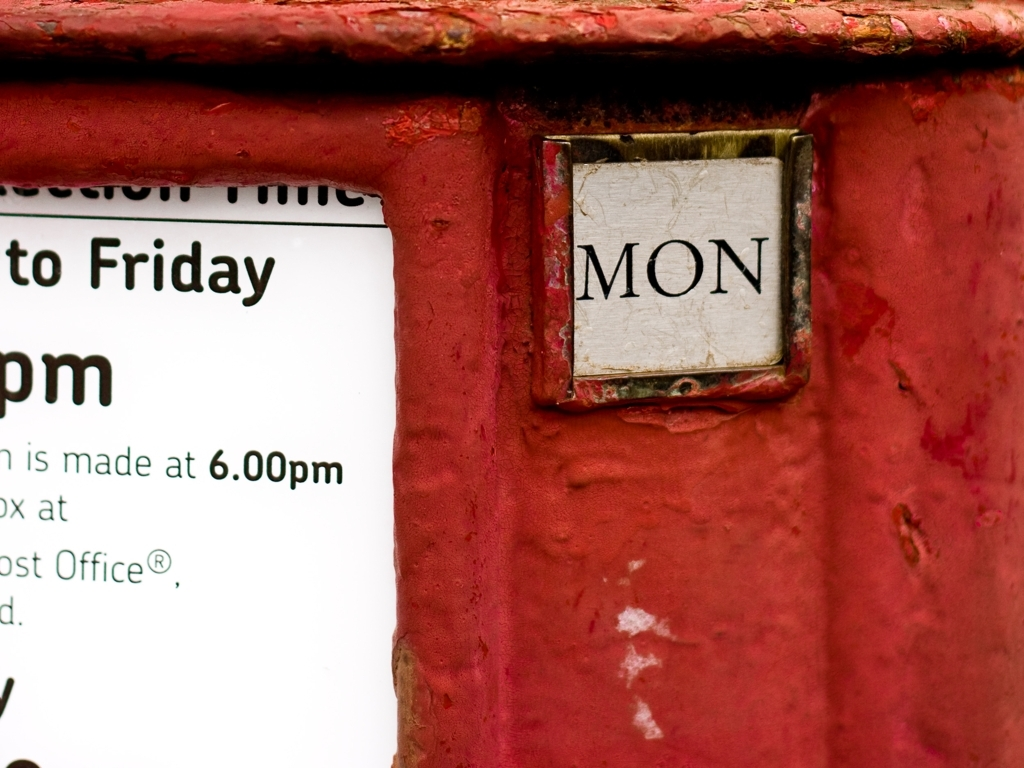Can you tell me anything about the history or significance of such signs on postal boxes? Signs like this are embedded in the rich history of postal services. They traditionally indicate the collection times and often include the day of the week to guide the public. Such methods date back to when communicating the specific timings for mail collection was crucial for efficient postal service operations. 